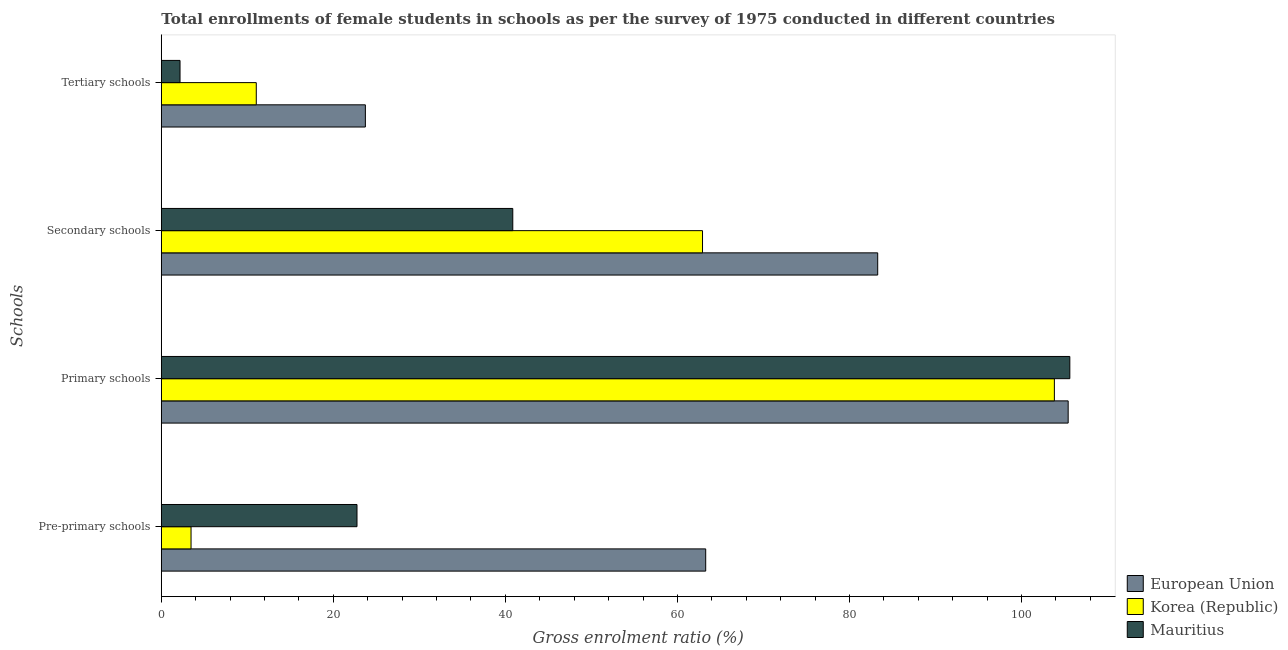How many different coloured bars are there?
Your response must be concise. 3. How many groups of bars are there?
Give a very brief answer. 4. Are the number of bars per tick equal to the number of legend labels?
Your answer should be compact. Yes. How many bars are there on the 2nd tick from the bottom?
Make the answer very short. 3. What is the label of the 1st group of bars from the top?
Make the answer very short. Tertiary schools. What is the gross enrolment ratio(female) in secondary schools in Korea (Republic)?
Make the answer very short. 62.92. Across all countries, what is the maximum gross enrolment ratio(female) in pre-primary schools?
Ensure brevity in your answer.  63.29. Across all countries, what is the minimum gross enrolment ratio(female) in secondary schools?
Keep it short and to the point. 40.86. In which country was the gross enrolment ratio(female) in primary schools minimum?
Your response must be concise. Korea (Republic). What is the total gross enrolment ratio(female) in secondary schools in the graph?
Your answer should be compact. 187.07. What is the difference between the gross enrolment ratio(female) in primary schools in Mauritius and that in Korea (Republic)?
Keep it short and to the point. 1.8. What is the difference between the gross enrolment ratio(female) in pre-primary schools in European Union and the gross enrolment ratio(female) in primary schools in Korea (Republic)?
Provide a succinct answer. -40.54. What is the average gross enrolment ratio(female) in tertiary schools per country?
Ensure brevity in your answer.  12.31. What is the difference between the gross enrolment ratio(female) in tertiary schools and gross enrolment ratio(female) in secondary schools in Mauritius?
Your response must be concise. -38.69. In how many countries, is the gross enrolment ratio(female) in primary schools greater than 4 %?
Provide a succinct answer. 3. What is the ratio of the gross enrolment ratio(female) in tertiary schools in Mauritius to that in European Union?
Offer a terse response. 0.09. Is the difference between the gross enrolment ratio(female) in tertiary schools in Korea (Republic) and European Union greater than the difference between the gross enrolment ratio(female) in pre-primary schools in Korea (Republic) and European Union?
Offer a terse response. Yes. What is the difference between the highest and the second highest gross enrolment ratio(female) in primary schools?
Provide a succinct answer. 0.19. What is the difference between the highest and the lowest gross enrolment ratio(female) in tertiary schools?
Give a very brief answer. 21.55. Is it the case that in every country, the sum of the gross enrolment ratio(female) in pre-primary schools and gross enrolment ratio(female) in primary schools is greater than the gross enrolment ratio(female) in secondary schools?
Ensure brevity in your answer.  Yes. How many bars are there?
Make the answer very short. 12. Are all the bars in the graph horizontal?
Offer a terse response. Yes. How many countries are there in the graph?
Provide a succinct answer. 3. Are the values on the major ticks of X-axis written in scientific E-notation?
Your answer should be compact. No. Where does the legend appear in the graph?
Make the answer very short. Bottom right. What is the title of the graph?
Your answer should be compact. Total enrollments of female students in schools as per the survey of 1975 conducted in different countries. Does "Qatar" appear as one of the legend labels in the graph?
Your answer should be very brief. No. What is the label or title of the Y-axis?
Offer a very short reply. Schools. What is the Gross enrolment ratio (%) of European Union in Pre-primary schools?
Your answer should be compact. 63.29. What is the Gross enrolment ratio (%) in Korea (Republic) in Pre-primary schools?
Provide a short and direct response. 3.46. What is the Gross enrolment ratio (%) in Mauritius in Pre-primary schools?
Offer a terse response. 22.75. What is the Gross enrolment ratio (%) in European Union in Primary schools?
Provide a succinct answer. 105.43. What is the Gross enrolment ratio (%) of Korea (Republic) in Primary schools?
Offer a terse response. 103.83. What is the Gross enrolment ratio (%) in Mauritius in Primary schools?
Provide a succinct answer. 105.62. What is the Gross enrolment ratio (%) of European Union in Secondary schools?
Your answer should be very brief. 83.29. What is the Gross enrolment ratio (%) in Korea (Republic) in Secondary schools?
Provide a succinct answer. 62.92. What is the Gross enrolment ratio (%) in Mauritius in Secondary schools?
Keep it short and to the point. 40.86. What is the Gross enrolment ratio (%) in European Union in Tertiary schools?
Make the answer very short. 23.72. What is the Gross enrolment ratio (%) of Korea (Republic) in Tertiary schools?
Ensure brevity in your answer.  11.04. What is the Gross enrolment ratio (%) of Mauritius in Tertiary schools?
Your response must be concise. 2.18. Across all Schools, what is the maximum Gross enrolment ratio (%) of European Union?
Provide a succinct answer. 105.43. Across all Schools, what is the maximum Gross enrolment ratio (%) of Korea (Republic)?
Your answer should be very brief. 103.83. Across all Schools, what is the maximum Gross enrolment ratio (%) of Mauritius?
Ensure brevity in your answer.  105.62. Across all Schools, what is the minimum Gross enrolment ratio (%) of European Union?
Your answer should be very brief. 23.72. Across all Schools, what is the minimum Gross enrolment ratio (%) in Korea (Republic)?
Provide a succinct answer. 3.46. Across all Schools, what is the minimum Gross enrolment ratio (%) of Mauritius?
Provide a succinct answer. 2.18. What is the total Gross enrolment ratio (%) in European Union in the graph?
Your response must be concise. 275.73. What is the total Gross enrolment ratio (%) of Korea (Republic) in the graph?
Your response must be concise. 181.24. What is the total Gross enrolment ratio (%) of Mauritius in the graph?
Your answer should be very brief. 171.41. What is the difference between the Gross enrolment ratio (%) of European Union in Pre-primary schools and that in Primary schools?
Provide a succinct answer. -42.14. What is the difference between the Gross enrolment ratio (%) in Korea (Republic) in Pre-primary schools and that in Primary schools?
Provide a succinct answer. -100.37. What is the difference between the Gross enrolment ratio (%) in Mauritius in Pre-primary schools and that in Primary schools?
Offer a very short reply. -82.87. What is the difference between the Gross enrolment ratio (%) in European Union in Pre-primary schools and that in Secondary schools?
Your answer should be compact. -20. What is the difference between the Gross enrolment ratio (%) of Korea (Republic) in Pre-primary schools and that in Secondary schools?
Provide a succinct answer. -59.46. What is the difference between the Gross enrolment ratio (%) of Mauritius in Pre-primary schools and that in Secondary schools?
Your answer should be very brief. -18.11. What is the difference between the Gross enrolment ratio (%) in European Union in Pre-primary schools and that in Tertiary schools?
Ensure brevity in your answer.  39.57. What is the difference between the Gross enrolment ratio (%) of Korea (Republic) in Pre-primary schools and that in Tertiary schools?
Your answer should be compact. -7.58. What is the difference between the Gross enrolment ratio (%) of Mauritius in Pre-primary schools and that in Tertiary schools?
Provide a short and direct response. 20.57. What is the difference between the Gross enrolment ratio (%) of European Union in Primary schools and that in Secondary schools?
Your answer should be compact. 22.14. What is the difference between the Gross enrolment ratio (%) of Korea (Republic) in Primary schools and that in Secondary schools?
Make the answer very short. 40.91. What is the difference between the Gross enrolment ratio (%) of Mauritius in Primary schools and that in Secondary schools?
Give a very brief answer. 64.76. What is the difference between the Gross enrolment ratio (%) in European Union in Primary schools and that in Tertiary schools?
Provide a short and direct response. 81.71. What is the difference between the Gross enrolment ratio (%) of Korea (Republic) in Primary schools and that in Tertiary schools?
Offer a very short reply. 92.79. What is the difference between the Gross enrolment ratio (%) in Mauritius in Primary schools and that in Tertiary schools?
Keep it short and to the point. 103.45. What is the difference between the Gross enrolment ratio (%) of European Union in Secondary schools and that in Tertiary schools?
Your answer should be very brief. 59.56. What is the difference between the Gross enrolment ratio (%) of Korea (Republic) in Secondary schools and that in Tertiary schools?
Your answer should be compact. 51.88. What is the difference between the Gross enrolment ratio (%) of Mauritius in Secondary schools and that in Tertiary schools?
Make the answer very short. 38.69. What is the difference between the Gross enrolment ratio (%) in European Union in Pre-primary schools and the Gross enrolment ratio (%) in Korea (Republic) in Primary schools?
Provide a short and direct response. -40.54. What is the difference between the Gross enrolment ratio (%) of European Union in Pre-primary schools and the Gross enrolment ratio (%) of Mauritius in Primary schools?
Your response must be concise. -42.33. What is the difference between the Gross enrolment ratio (%) in Korea (Republic) in Pre-primary schools and the Gross enrolment ratio (%) in Mauritius in Primary schools?
Offer a terse response. -102.17. What is the difference between the Gross enrolment ratio (%) in European Union in Pre-primary schools and the Gross enrolment ratio (%) in Korea (Republic) in Secondary schools?
Your answer should be very brief. 0.37. What is the difference between the Gross enrolment ratio (%) of European Union in Pre-primary schools and the Gross enrolment ratio (%) of Mauritius in Secondary schools?
Keep it short and to the point. 22.43. What is the difference between the Gross enrolment ratio (%) in Korea (Republic) in Pre-primary schools and the Gross enrolment ratio (%) in Mauritius in Secondary schools?
Offer a terse response. -37.41. What is the difference between the Gross enrolment ratio (%) of European Union in Pre-primary schools and the Gross enrolment ratio (%) of Korea (Republic) in Tertiary schools?
Your answer should be very brief. 52.25. What is the difference between the Gross enrolment ratio (%) of European Union in Pre-primary schools and the Gross enrolment ratio (%) of Mauritius in Tertiary schools?
Provide a short and direct response. 61.12. What is the difference between the Gross enrolment ratio (%) in Korea (Republic) in Pre-primary schools and the Gross enrolment ratio (%) in Mauritius in Tertiary schools?
Offer a terse response. 1.28. What is the difference between the Gross enrolment ratio (%) in European Union in Primary schools and the Gross enrolment ratio (%) in Korea (Republic) in Secondary schools?
Give a very brief answer. 42.51. What is the difference between the Gross enrolment ratio (%) of European Union in Primary schools and the Gross enrolment ratio (%) of Mauritius in Secondary schools?
Your answer should be very brief. 64.57. What is the difference between the Gross enrolment ratio (%) of Korea (Republic) in Primary schools and the Gross enrolment ratio (%) of Mauritius in Secondary schools?
Your answer should be very brief. 62.96. What is the difference between the Gross enrolment ratio (%) in European Union in Primary schools and the Gross enrolment ratio (%) in Korea (Republic) in Tertiary schools?
Give a very brief answer. 94.39. What is the difference between the Gross enrolment ratio (%) in European Union in Primary schools and the Gross enrolment ratio (%) in Mauritius in Tertiary schools?
Keep it short and to the point. 103.25. What is the difference between the Gross enrolment ratio (%) of Korea (Republic) in Primary schools and the Gross enrolment ratio (%) of Mauritius in Tertiary schools?
Provide a succinct answer. 101.65. What is the difference between the Gross enrolment ratio (%) of European Union in Secondary schools and the Gross enrolment ratio (%) of Korea (Republic) in Tertiary schools?
Provide a succinct answer. 72.25. What is the difference between the Gross enrolment ratio (%) of European Union in Secondary schools and the Gross enrolment ratio (%) of Mauritius in Tertiary schools?
Ensure brevity in your answer.  81.11. What is the difference between the Gross enrolment ratio (%) of Korea (Republic) in Secondary schools and the Gross enrolment ratio (%) of Mauritius in Tertiary schools?
Make the answer very short. 60.74. What is the average Gross enrolment ratio (%) in European Union per Schools?
Make the answer very short. 68.93. What is the average Gross enrolment ratio (%) in Korea (Republic) per Schools?
Your response must be concise. 45.31. What is the average Gross enrolment ratio (%) of Mauritius per Schools?
Your response must be concise. 42.85. What is the difference between the Gross enrolment ratio (%) of European Union and Gross enrolment ratio (%) of Korea (Republic) in Pre-primary schools?
Ensure brevity in your answer.  59.83. What is the difference between the Gross enrolment ratio (%) of European Union and Gross enrolment ratio (%) of Mauritius in Pre-primary schools?
Your answer should be compact. 40.54. What is the difference between the Gross enrolment ratio (%) in Korea (Republic) and Gross enrolment ratio (%) in Mauritius in Pre-primary schools?
Your answer should be compact. -19.29. What is the difference between the Gross enrolment ratio (%) of European Union and Gross enrolment ratio (%) of Korea (Republic) in Primary schools?
Your response must be concise. 1.6. What is the difference between the Gross enrolment ratio (%) in European Union and Gross enrolment ratio (%) in Mauritius in Primary schools?
Offer a terse response. -0.19. What is the difference between the Gross enrolment ratio (%) of Korea (Republic) and Gross enrolment ratio (%) of Mauritius in Primary schools?
Your answer should be very brief. -1.8. What is the difference between the Gross enrolment ratio (%) of European Union and Gross enrolment ratio (%) of Korea (Republic) in Secondary schools?
Offer a terse response. 20.37. What is the difference between the Gross enrolment ratio (%) of European Union and Gross enrolment ratio (%) of Mauritius in Secondary schools?
Provide a short and direct response. 42.42. What is the difference between the Gross enrolment ratio (%) in Korea (Republic) and Gross enrolment ratio (%) in Mauritius in Secondary schools?
Offer a very short reply. 22.06. What is the difference between the Gross enrolment ratio (%) in European Union and Gross enrolment ratio (%) in Korea (Republic) in Tertiary schools?
Ensure brevity in your answer.  12.68. What is the difference between the Gross enrolment ratio (%) in European Union and Gross enrolment ratio (%) in Mauritius in Tertiary schools?
Provide a succinct answer. 21.55. What is the difference between the Gross enrolment ratio (%) in Korea (Republic) and Gross enrolment ratio (%) in Mauritius in Tertiary schools?
Keep it short and to the point. 8.87. What is the ratio of the Gross enrolment ratio (%) in European Union in Pre-primary schools to that in Primary schools?
Ensure brevity in your answer.  0.6. What is the ratio of the Gross enrolment ratio (%) in Mauritius in Pre-primary schools to that in Primary schools?
Provide a succinct answer. 0.22. What is the ratio of the Gross enrolment ratio (%) of European Union in Pre-primary schools to that in Secondary schools?
Your answer should be compact. 0.76. What is the ratio of the Gross enrolment ratio (%) in Korea (Republic) in Pre-primary schools to that in Secondary schools?
Your answer should be compact. 0.05. What is the ratio of the Gross enrolment ratio (%) of Mauritius in Pre-primary schools to that in Secondary schools?
Keep it short and to the point. 0.56. What is the ratio of the Gross enrolment ratio (%) in European Union in Pre-primary schools to that in Tertiary schools?
Make the answer very short. 2.67. What is the ratio of the Gross enrolment ratio (%) of Korea (Republic) in Pre-primary schools to that in Tertiary schools?
Give a very brief answer. 0.31. What is the ratio of the Gross enrolment ratio (%) of Mauritius in Pre-primary schools to that in Tertiary schools?
Provide a succinct answer. 10.46. What is the ratio of the Gross enrolment ratio (%) of European Union in Primary schools to that in Secondary schools?
Your answer should be compact. 1.27. What is the ratio of the Gross enrolment ratio (%) in Korea (Republic) in Primary schools to that in Secondary schools?
Provide a succinct answer. 1.65. What is the ratio of the Gross enrolment ratio (%) of Mauritius in Primary schools to that in Secondary schools?
Ensure brevity in your answer.  2.58. What is the ratio of the Gross enrolment ratio (%) in European Union in Primary schools to that in Tertiary schools?
Give a very brief answer. 4.44. What is the ratio of the Gross enrolment ratio (%) of Korea (Republic) in Primary schools to that in Tertiary schools?
Provide a short and direct response. 9.4. What is the ratio of the Gross enrolment ratio (%) of Mauritius in Primary schools to that in Tertiary schools?
Provide a short and direct response. 48.56. What is the ratio of the Gross enrolment ratio (%) of European Union in Secondary schools to that in Tertiary schools?
Provide a succinct answer. 3.51. What is the ratio of the Gross enrolment ratio (%) in Korea (Republic) in Secondary schools to that in Tertiary schools?
Make the answer very short. 5.7. What is the ratio of the Gross enrolment ratio (%) of Mauritius in Secondary schools to that in Tertiary schools?
Offer a terse response. 18.79. What is the difference between the highest and the second highest Gross enrolment ratio (%) of European Union?
Your answer should be compact. 22.14. What is the difference between the highest and the second highest Gross enrolment ratio (%) of Korea (Republic)?
Your response must be concise. 40.91. What is the difference between the highest and the second highest Gross enrolment ratio (%) of Mauritius?
Offer a terse response. 64.76. What is the difference between the highest and the lowest Gross enrolment ratio (%) of European Union?
Your answer should be very brief. 81.71. What is the difference between the highest and the lowest Gross enrolment ratio (%) of Korea (Republic)?
Give a very brief answer. 100.37. What is the difference between the highest and the lowest Gross enrolment ratio (%) of Mauritius?
Your answer should be compact. 103.45. 